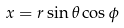<formula> <loc_0><loc_0><loc_500><loc_500>x = r \sin \theta \cos \phi</formula> 